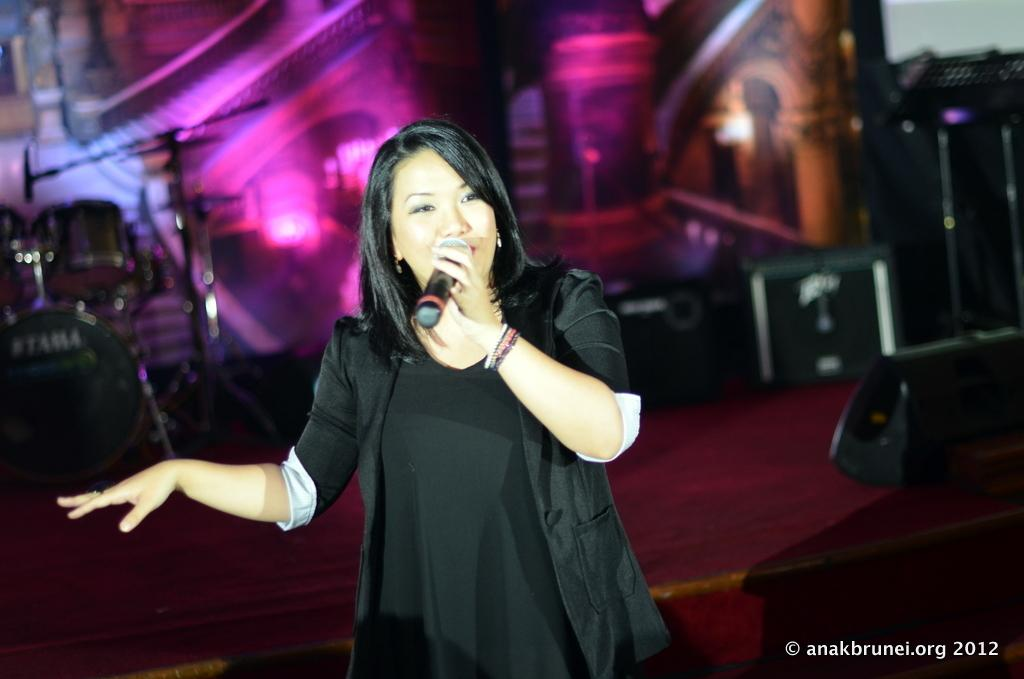Who is the main subject in the image? There is a woman in the image. What is the woman holding in the image? The woman is holding a mic. What is the woman wearing in the image? The woman is wearing a black dress. What else can be seen on the stage in the image? There are musical instruments on the stage. How would you describe the background of the image? The background of the image is colorful. Can you see any islands in the image? There are no islands visible in the image. What type of unit is being measured by the woman in the image? The woman is holding a mic, not measuring any units in the image. 